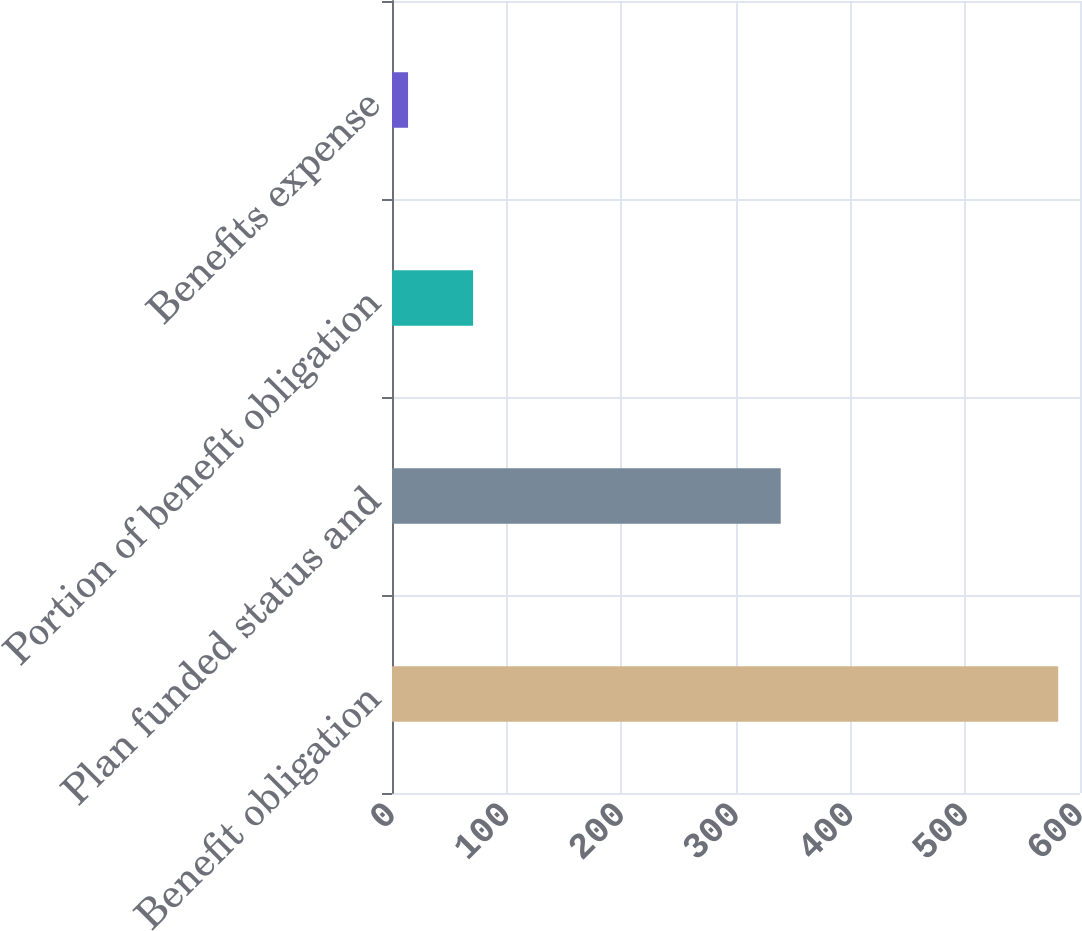<chart> <loc_0><loc_0><loc_500><loc_500><bar_chart><fcel>Benefit obligation<fcel>Plan funded status and<fcel>Portion of benefit obligation<fcel>Benefits expense<nl><fcel>581<fcel>339<fcel>70.7<fcel>14<nl></chart> 